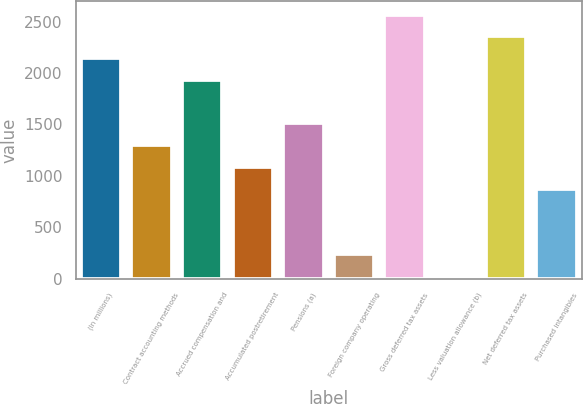<chart> <loc_0><loc_0><loc_500><loc_500><bar_chart><fcel>(In millions)<fcel>Contract accounting methods<fcel>Accrued compensation and<fcel>Accumulated postretirement<fcel>Pensions (a)<fcel>Foreign company operating<fcel>Gross deferred tax assets<fcel>Less valuation allowance (b)<fcel>Net deferred tax assets<fcel>Purchased intangibles<nl><fcel>2145<fcel>1299<fcel>1933.5<fcel>1087.5<fcel>1510.5<fcel>241.5<fcel>2568<fcel>30<fcel>2356.5<fcel>876<nl></chart> 